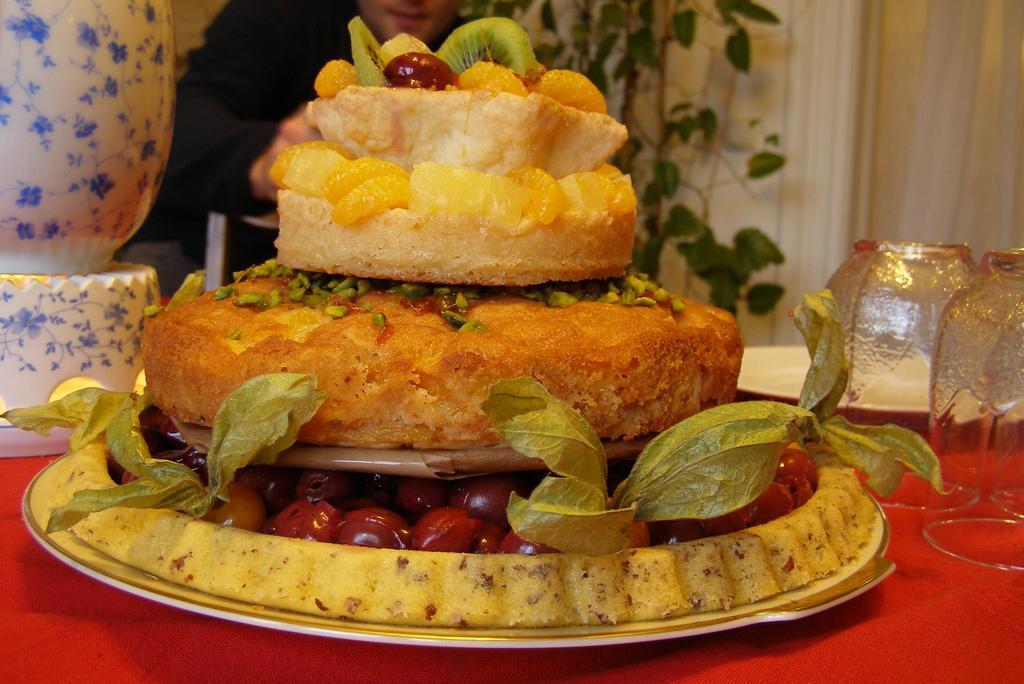How would you summarize this image in a sentence or two? In this image in front there are food items, glasses, plate and a few other objects on the table. Behind the table there is a person. There is a plant. There are curtains. 